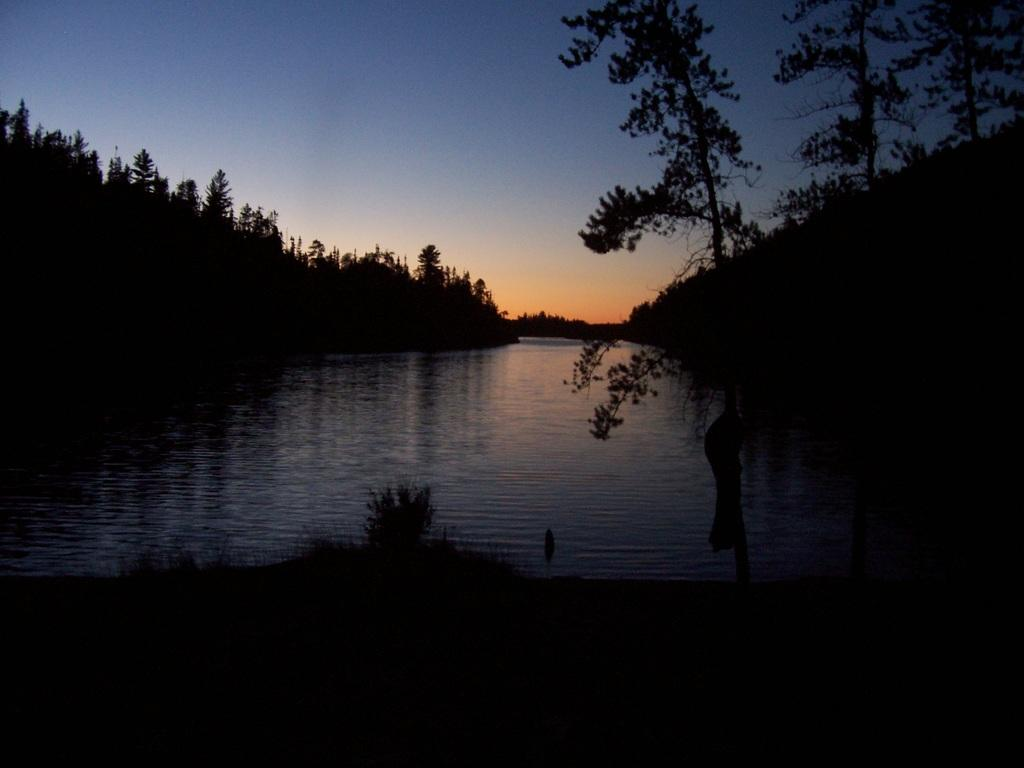What is the primary element visible in the image? There is water in the image. What can be seen near the water? There are trees beside the water. What color is the sky in the image? The sky is blue in color. Can you see any pears floating in the water in the image? There are no pears visible in the image; it only features water, trees, and a blue sky. 